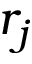<formula> <loc_0><loc_0><loc_500><loc_500>r _ { j }</formula> 